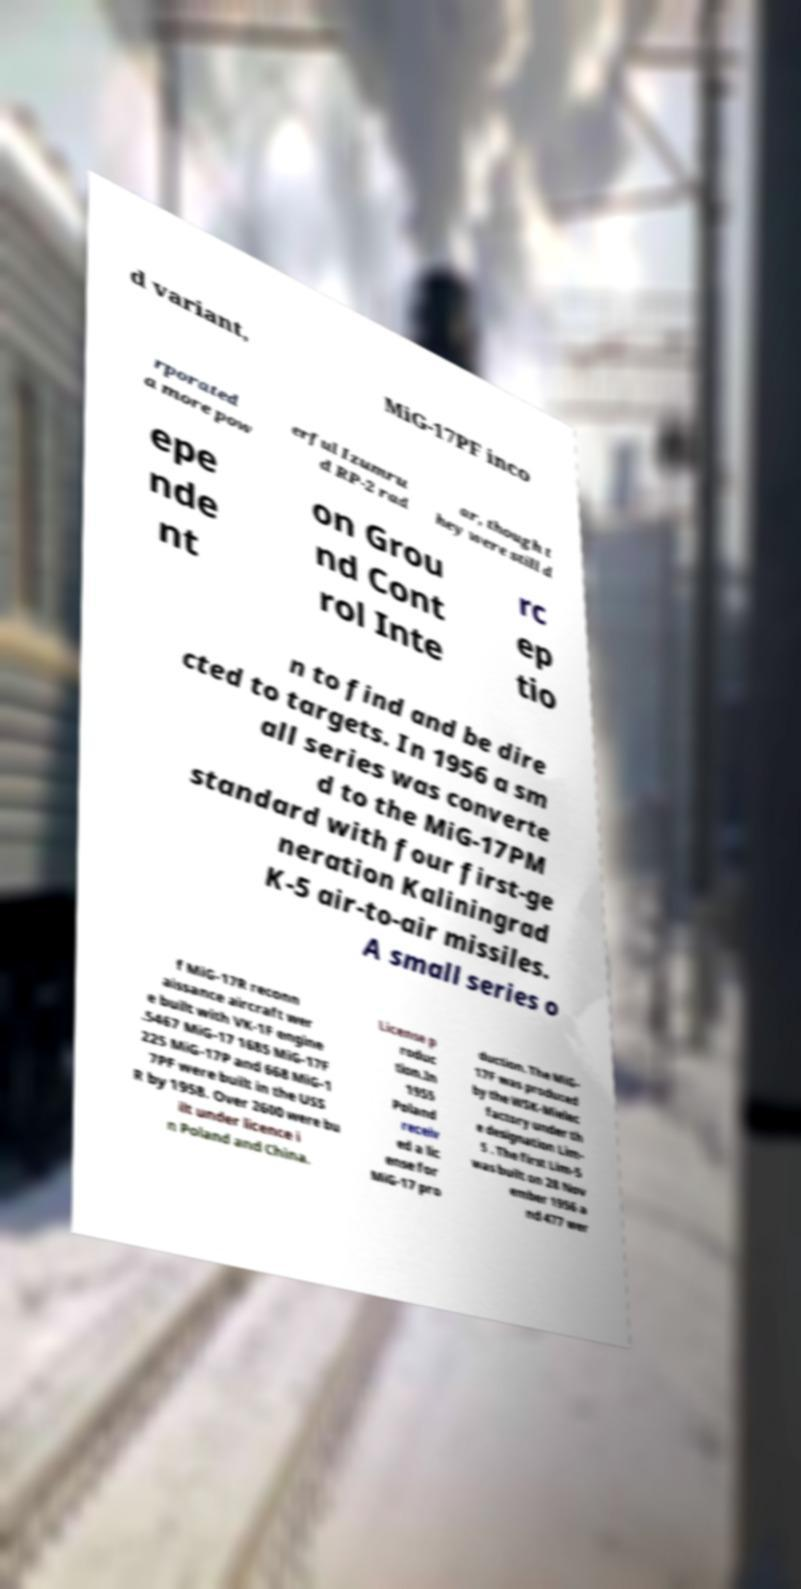What messages or text are displayed in this image? I need them in a readable, typed format. d variant, MiG-17PF inco rporated a more pow erful Izumru d RP-2 rad ar, though t hey were still d epe nde nt on Grou nd Cont rol Inte rc ep tio n to find and be dire cted to targets. In 1956 a sm all series was converte d to the MiG-17PM standard with four first-ge neration Kaliningrad K-5 air-to-air missiles. A small series o f MiG-17R reconn aissance aircraft wer e built with VK-1F engine .5467 MiG-17 1685 MiG-17F 225 MiG-17P and 668 MiG-1 7PF were built in the USS R by 1958. Over 2600 were bu ilt under licence i n Poland and China. License p roduc tion.In 1955 Poland receiv ed a lic ense for MiG-17 pro duction. The MiG- 17F was produced by the WSK-Mielec factory under th e designation Lim- 5 . The first Lim-5 was built on 28 Nov ember 1956 a nd 477 wer 